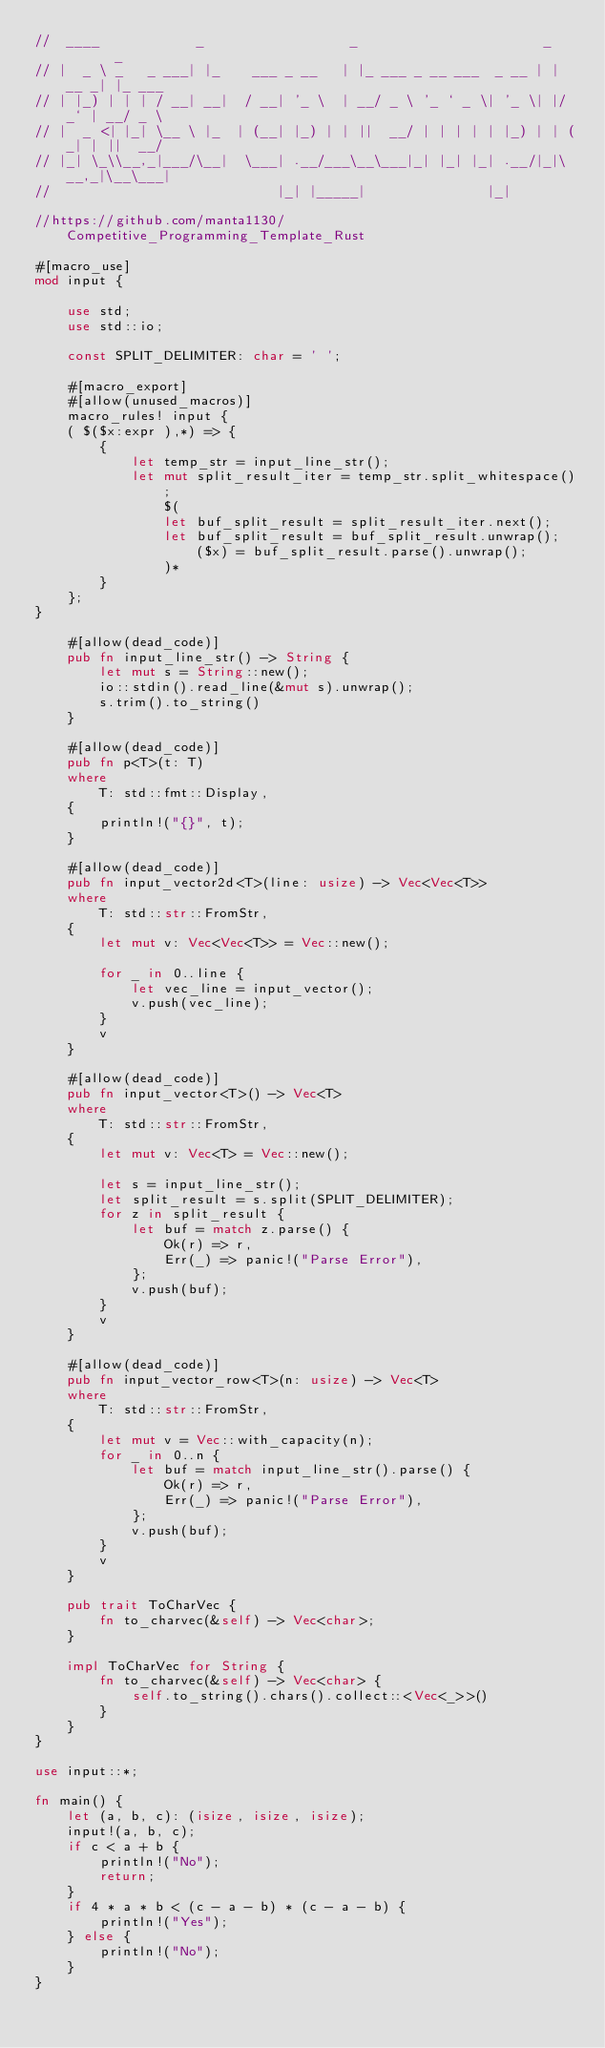<code> <loc_0><loc_0><loc_500><loc_500><_Rust_>//  ____            _                  _                       _       _
// |  _ \ _   _ ___| |_    ___ _ __   | |_ ___ _ __ ___  _ __ | | __ _| |_ ___
// | |_) | | | / __| __|  / __| '_ \  | __/ _ \ '_ ` _ \| '_ \| |/ _` | __/ _ \
// |  _ <| |_| \__ \ |_  | (__| |_) | | ||  __/ | | | | | |_) | | (_| | ||  __/
// |_| \_\\__,_|___/\__|  \___| .__/___\__\___|_| |_| |_| .__/|_|\__,_|\__\___|
//                            |_| |_____|               |_|

//https://github.com/manta1130/Competitive_Programming_Template_Rust

#[macro_use]
mod input {

    use std;
    use std::io;

    const SPLIT_DELIMITER: char = ' ';

    #[macro_export]
    #[allow(unused_macros)]
    macro_rules! input {
    ( $($x:expr ),*) => {
        {
            let temp_str = input_line_str();
            let mut split_result_iter = temp_str.split_whitespace();
                $(
                let buf_split_result = split_result_iter.next();
                let buf_split_result = buf_split_result.unwrap();
                    ($x) = buf_split_result.parse().unwrap();
                )*
        }
    };
}

    #[allow(dead_code)]
    pub fn input_line_str() -> String {
        let mut s = String::new();
        io::stdin().read_line(&mut s).unwrap();
        s.trim().to_string()
    }

    #[allow(dead_code)]
    pub fn p<T>(t: T)
    where
        T: std::fmt::Display,
    {
        println!("{}", t);
    }

    #[allow(dead_code)]
    pub fn input_vector2d<T>(line: usize) -> Vec<Vec<T>>
    where
        T: std::str::FromStr,
    {
        let mut v: Vec<Vec<T>> = Vec::new();

        for _ in 0..line {
            let vec_line = input_vector();
            v.push(vec_line);
        }
        v
    }

    #[allow(dead_code)]
    pub fn input_vector<T>() -> Vec<T>
    where
        T: std::str::FromStr,
    {
        let mut v: Vec<T> = Vec::new();

        let s = input_line_str();
        let split_result = s.split(SPLIT_DELIMITER);
        for z in split_result {
            let buf = match z.parse() {
                Ok(r) => r,
                Err(_) => panic!("Parse Error"),
            };
            v.push(buf);
        }
        v
    }

    #[allow(dead_code)]
    pub fn input_vector_row<T>(n: usize) -> Vec<T>
    where
        T: std::str::FromStr,
    {
        let mut v = Vec::with_capacity(n);
        for _ in 0..n {
            let buf = match input_line_str().parse() {
                Ok(r) => r,
                Err(_) => panic!("Parse Error"),
            };
            v.push(buf);
        }
        v
    }

    pub trait ToCharVec {
        fn to_charvec(&self) -> Vec<char>;
    }

    impl ToCharVec for String {
        fn to_charvec(&self) -> Vec<char> {
            self.to_string().chars().collect::<Vec<_>>()
        }
    }
}

use input::*;

fn main() {
    let (a, b, c): (isize, isize, isize);
    input!(a, b, c);
    if c < a + b {
        println!("No");
        return;
    }
    if 4 * a * b < (c - a - b) * (c - a - b) {
        println!("Yes");
    } else {
        println!("No");
    }
}
</code> 